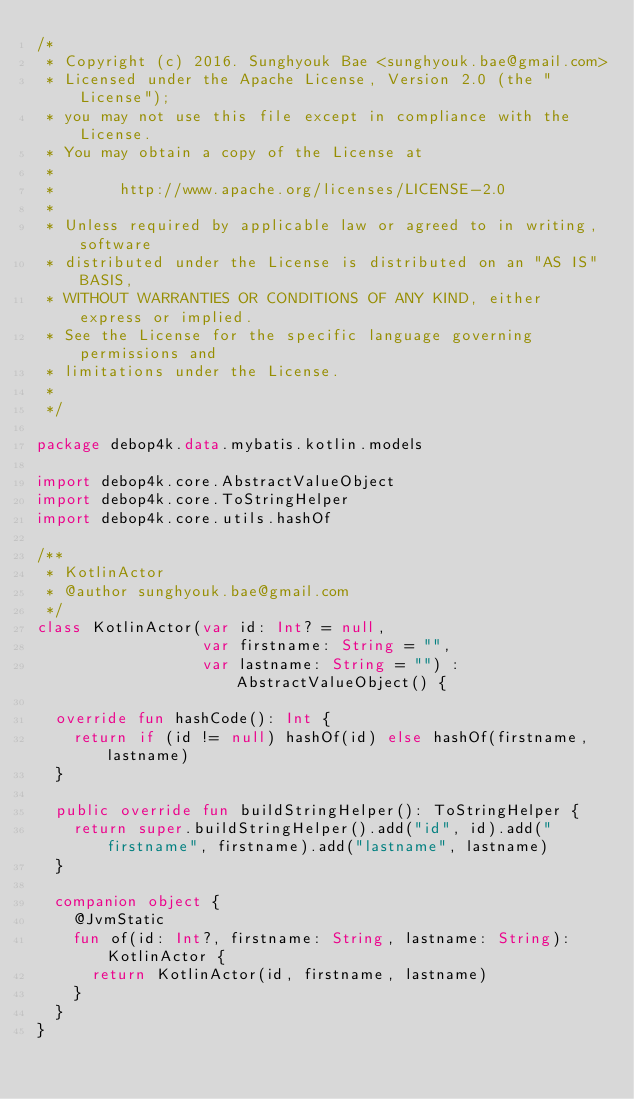<code> <loc_0><loc_0><loc_500><loc_500><_Kotlin_>/*
 * Copyright (c) 2016. Sunghyouk Bae <sunghyouk.bae@gmail.com>
 * Licensed under the Apache License, Version 2.0 (the "License");
 * you may not use this file except in compliance with the License.
 * You may obtain a copy of the License at
 *
 *       http://www.apache.org/licenses/LICENSE-2.0
 *
 * Unless required by applicable law or agreed to in writing, software
 * distributed under the License is distributed on an "AS IS" BASIS,
 * WITHOUT WARRANTIES OR CONDITIONS OF ANY KIND, either express or implied.
 * See the License for the specific language governing permissions and
 * limitations under the License.
 *
 */

package debop4k.data.mybatis.kotlin.models

import debop4k.core.AbstractValueObject
import debop4k.core.ToStringHelper
import debop4k.core.utils.hashOf

/**
 * KotlinActor
 * @author sunghyouk.bae@gmail.com
 */
class KotlinActor(var id: Int? = null,
                  var firstname: String = "",
                  var lastname: String = "") : AbstractValueObject() {

  override fun hashCode(): Int {
    return if (id != null) hashOf(id) else hashOf(firstname, lastname)
  }

  public override fun buildStringHelper(): ToStringHelper {
    return super.buildStringHelper().add("id", id).add("firstname", firstname).add("lastname", lastname)
  }

  companion object {
    @JvmStatic
    fun of(id: Int?, firstname: String, lastname: String): KotlinActor {
      return KotlinActor(id, firstname, lastname)
    }
  }
}</code> 